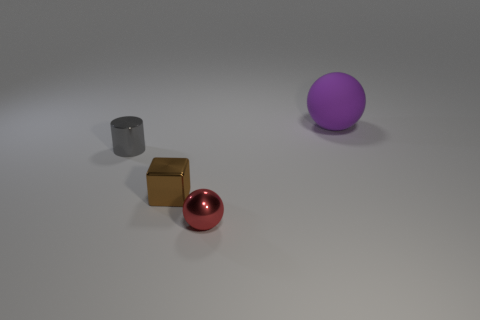What number of matte things are small brown objects or tiny yellow cubes?
Provide a short and direct response. 0. What is the color of the ball that is in front of the thing to the right of the ball that is to the left of the big purple matte ball?
Offer a very short reply. Red. How many other objects are the same material as the small red ball?
Offer a very short reply. 2. Is the shape of the metal object that is in front of the small cube the same as  the large object?
Your response must be concise. Yes. What number of tiny things are either blue blocks or gray metal things?
Make the answer very short. 1. Are there the same number of purple rubber things that are in front of the rubber sphere and things that are right of the tiny red ball?
Keep it short and to the point. No. What number of green things are either big metallic things or tiny objects?
Keep it short and to the point. 0. Is the number of brown metallic blocks that are right of the large matte thing the same as the number of tiny blue objects?
Your response must be concise. Yes. Is there anything else that has the same size as the purple rubber ball?
Keep it short and to the point. No. The shiny object that is the same shape as the rubber object is what color?
Keep it short and to the point. Red. 